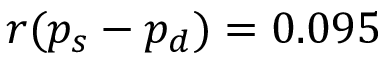Convert formula to latex. <formula><loc_0><loc_0><loc_500><loc_500>r ( p _ { s } - p _ { d } ) = 0 . 0 9 5</formula> 